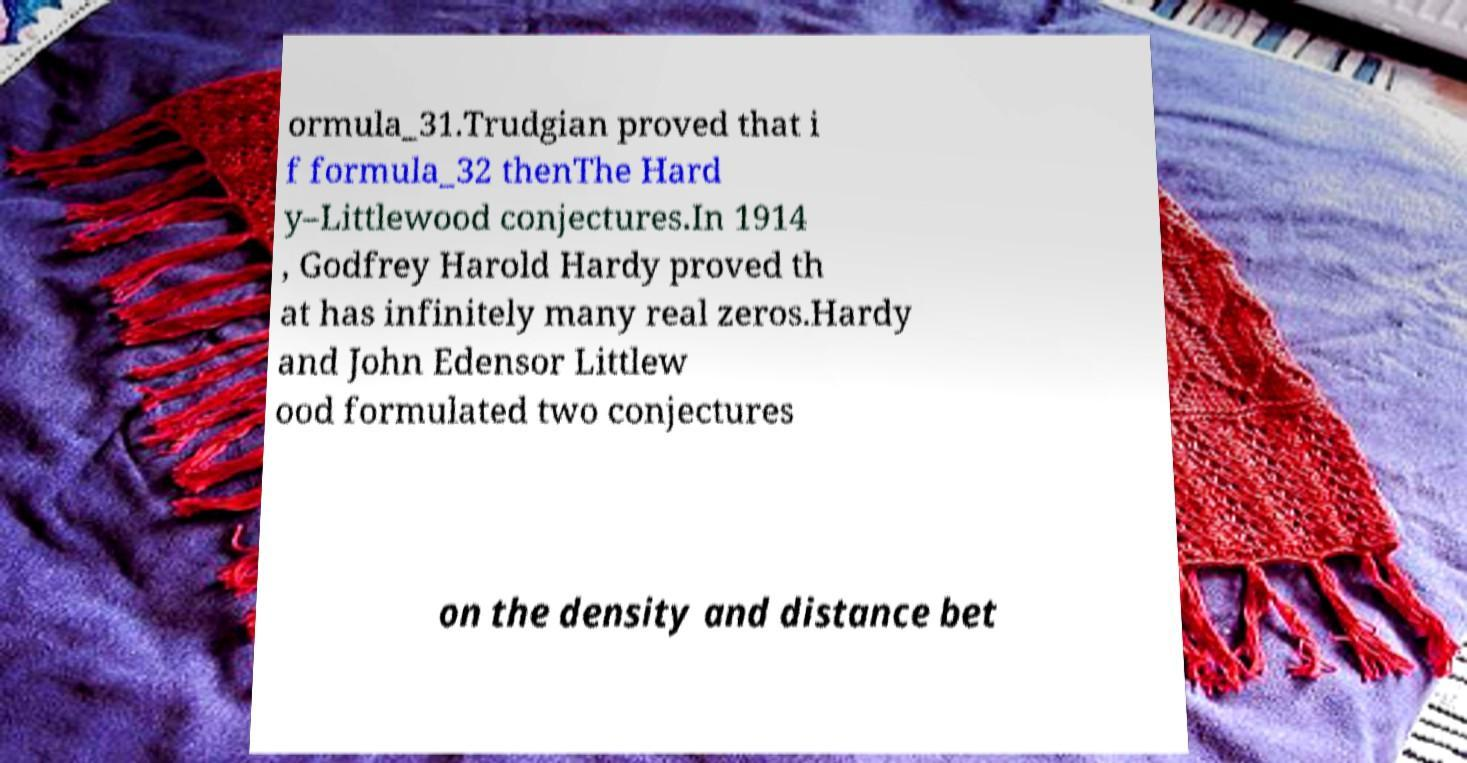Could you extract and type out the text from this image? ormula_31.Trudgian proved that i f formula_32 thenThe Hard y–Littlewood conjectures.In 1914 , Godfrey Harold Hardy proved th at has infinitely many real zeros.Hardy and John Edensor Littlew ood formulated two conjectures on the density and distance bet 